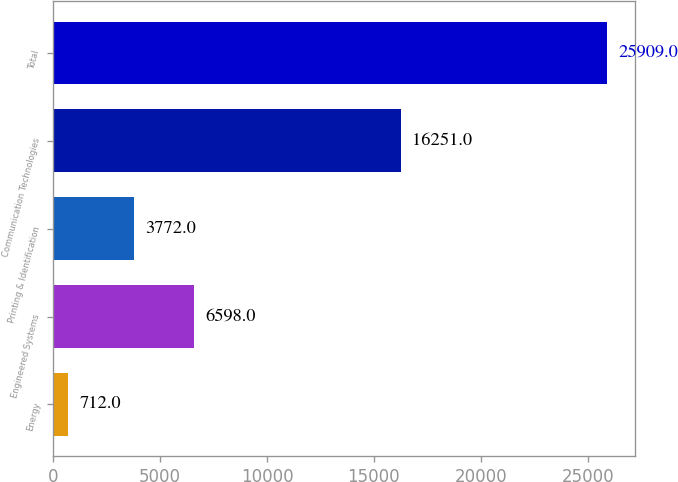Convert chart to OTSL. <chart><loc_0><loc_0><loc_500><loc_500><bar_chart><fcel>Energy<fcel>Engineered Systems<fcel>Printing & Identification<fcel>Communication Technologies<fcel>Total<nl><fcel>712<fcel>6598<fcel>3772<fcel>16251<fcel>25909<nl></chart> 